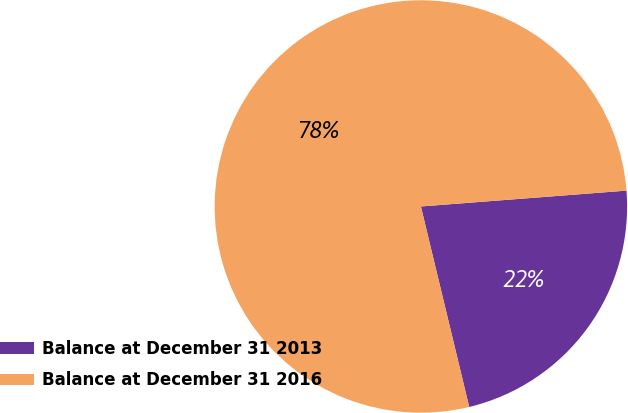<chart> <loc_0><loc_0><loc_500><loc_500><pie_chart><fcel>Balance at December 31 2013<fcel>Balance at December 31 2016<nl><fcel>22.46%<fcel>77.54%<nl></chart> 